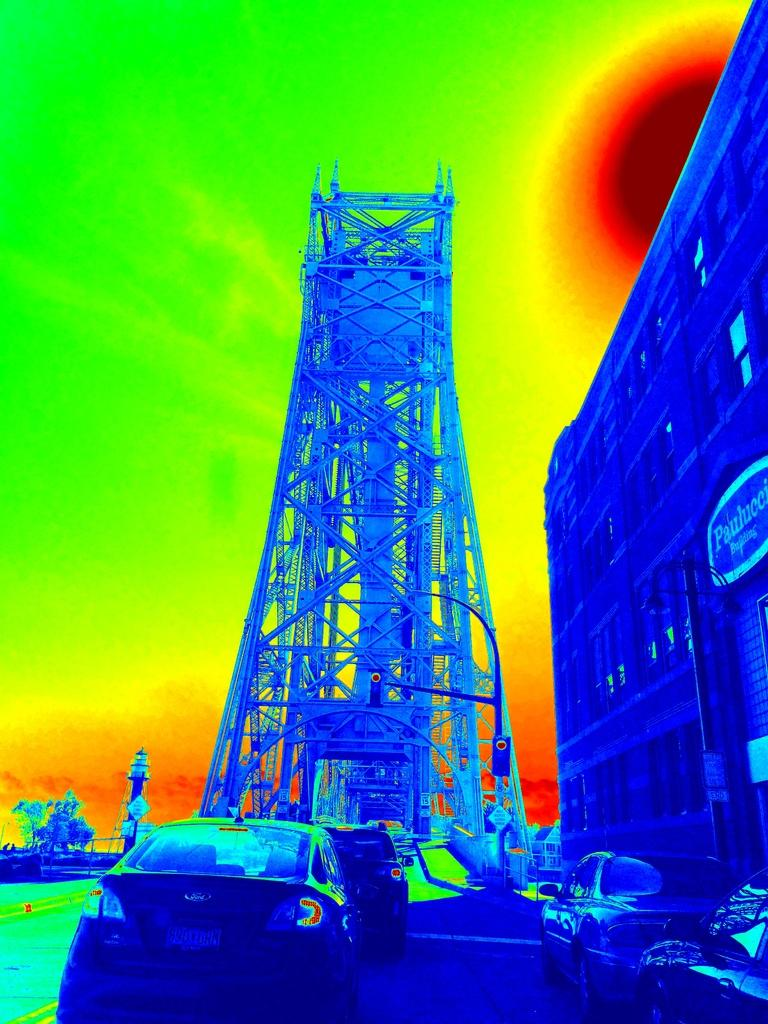How has the image been altered? The image has been edited. What types of vehicles can be seen in the image? There are vehicles in the image. What is the tall structure in the image? There is a tower in the image. What type of building is on the right side of the image? There is a building with windows on the right side of the image. What is the signage in the image? There is a name board in the image. What type of juice is being served at the birthday party in the image? There is no birthday party or juice present in the image. What type of blade is being used to cut the cake in the image? There is no cake or blade present in the image. 